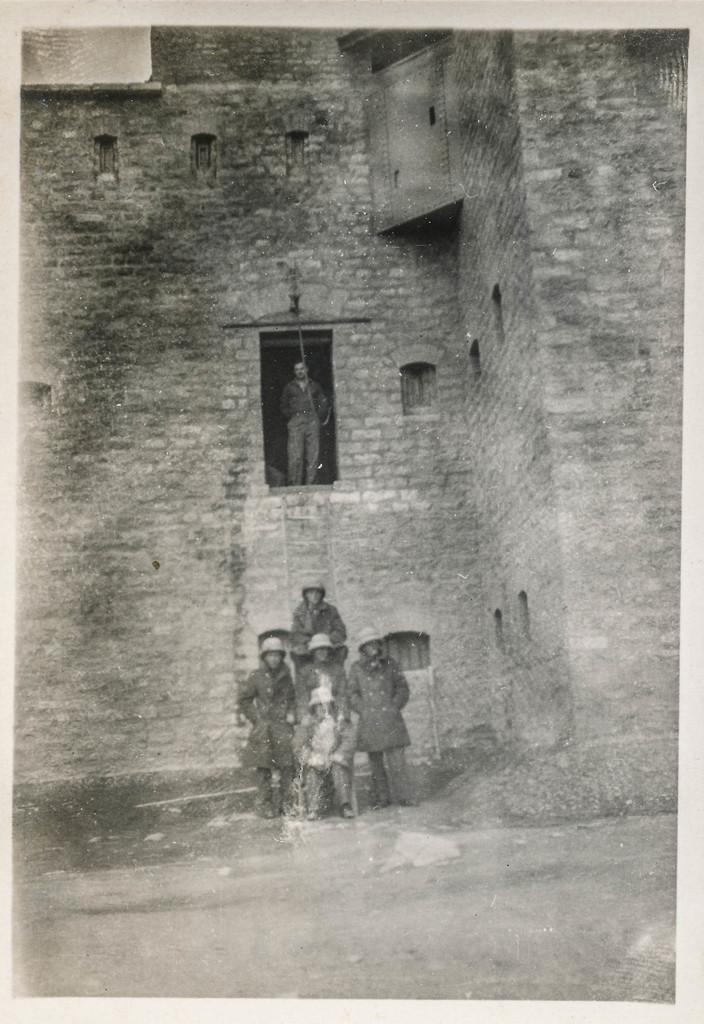Could you give a brief overview of what you see in this image? This is a black and white image. In the center of the image there are people standing. In the background of the image there is a building. There is a window in which there is a person. 